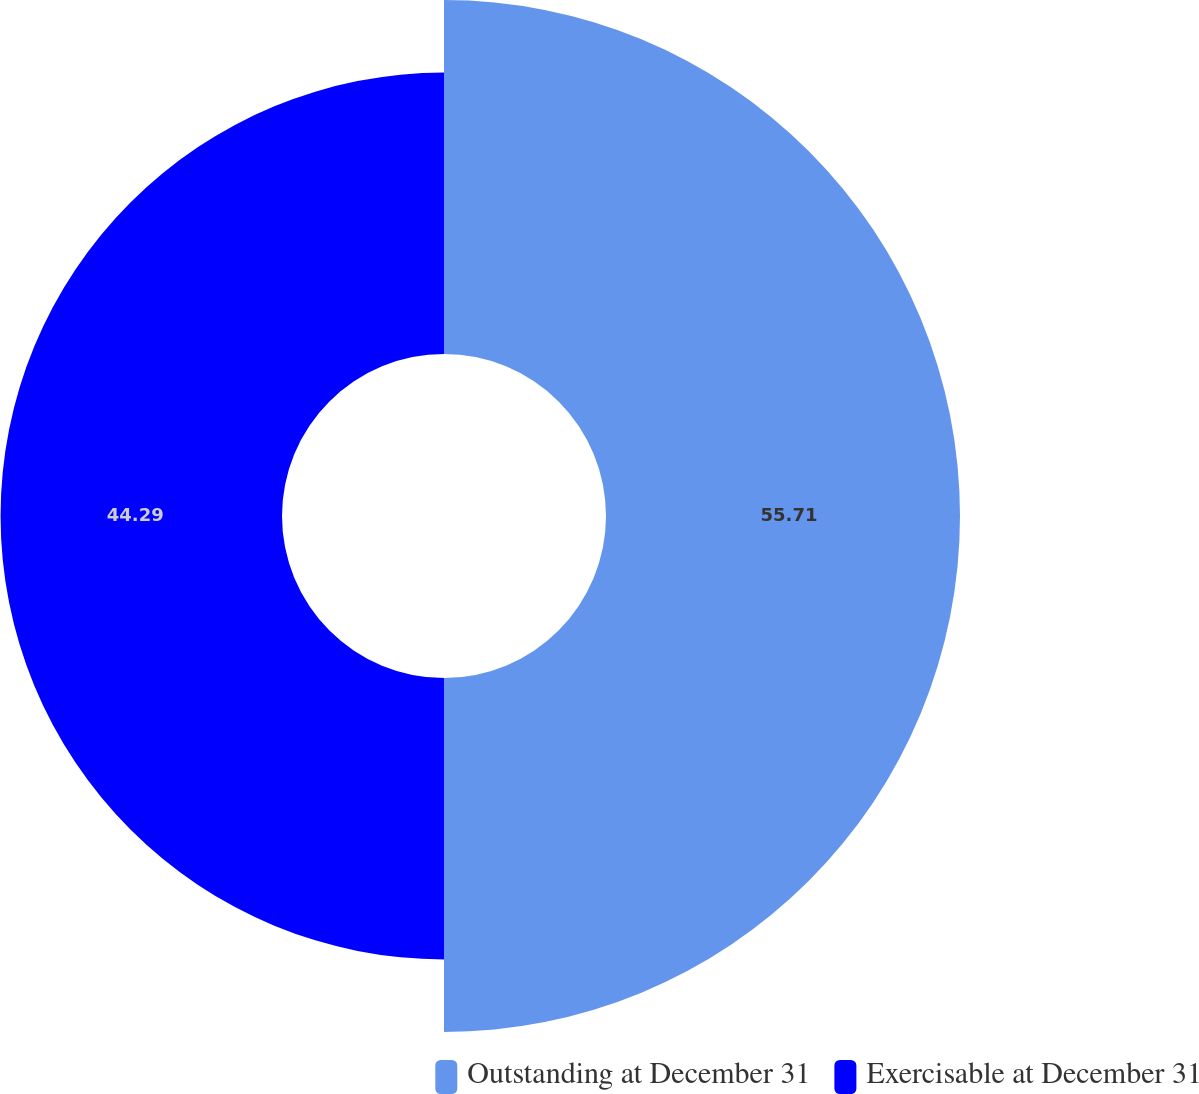Convert chart. <chart><loc_0><loc_0><loc_500><loc_500><pie_chart><fcel>Outstanding at December 31<fcel>Exercisable at December 31<nl><fcel>55.71%<fcel>44.29%<nl></chart> 